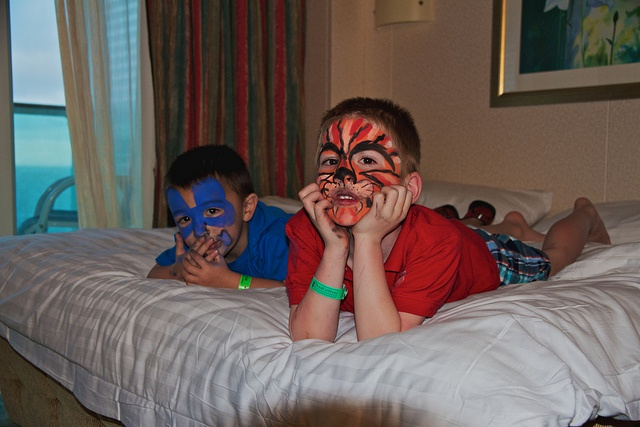Describe the objects in this image and their specific colors. I can see bed in black, darkgray, and gray tones, people in black, maroon, and brown tones, and people in black, navy, maroon, and gray tones in this image. 